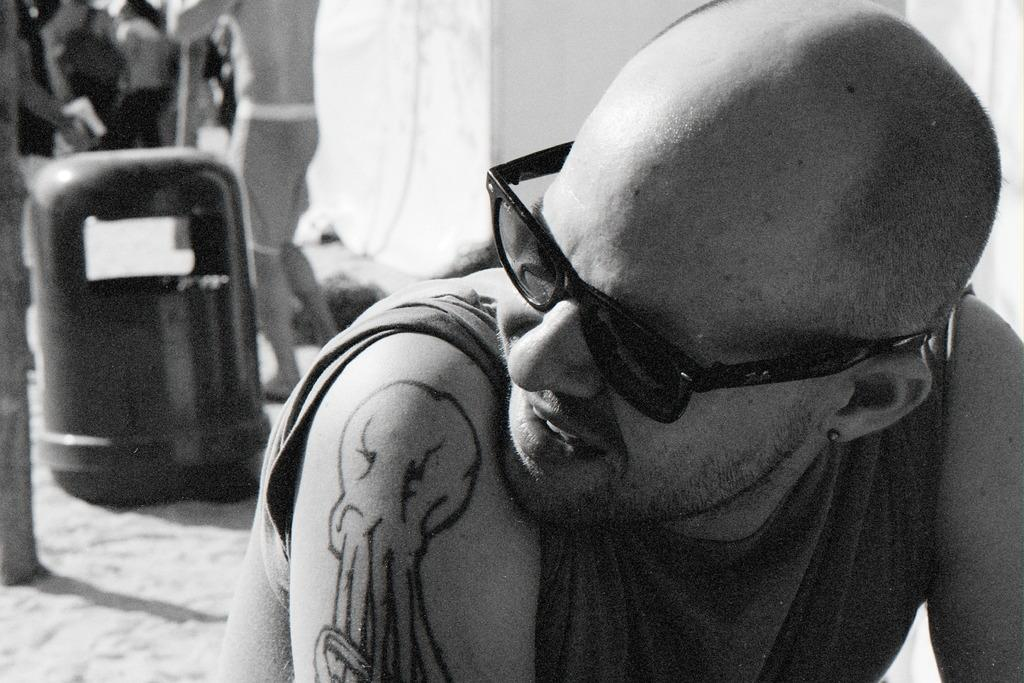What is the primary subject in the image? There is a person sitting in the image. What can be seen happening in the background of the image? There are people walking on the sand in the background of the image. What object is visible in the image that is typically used for waste disposal? There is a dustbin visible in the image. What type of hair can be seen on the cow in the image? There is no cow present in the image, so there is no hair to observe. 